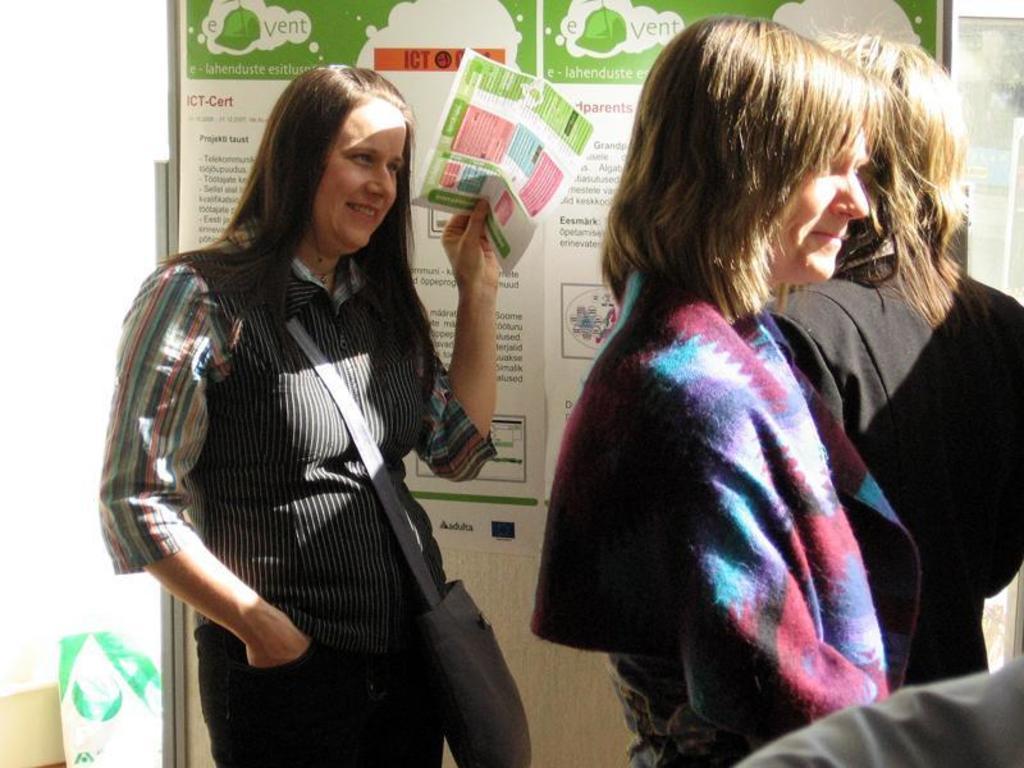How would you summarize this image in a sentence or two? In this image there are three persons, there is a person wearing a bag and holding a paper, there is a person truncated towards the right of the image, there is a board, there are posters on the board, there is text on the posters, there is an object on the floor, the background of the image is white in color. 